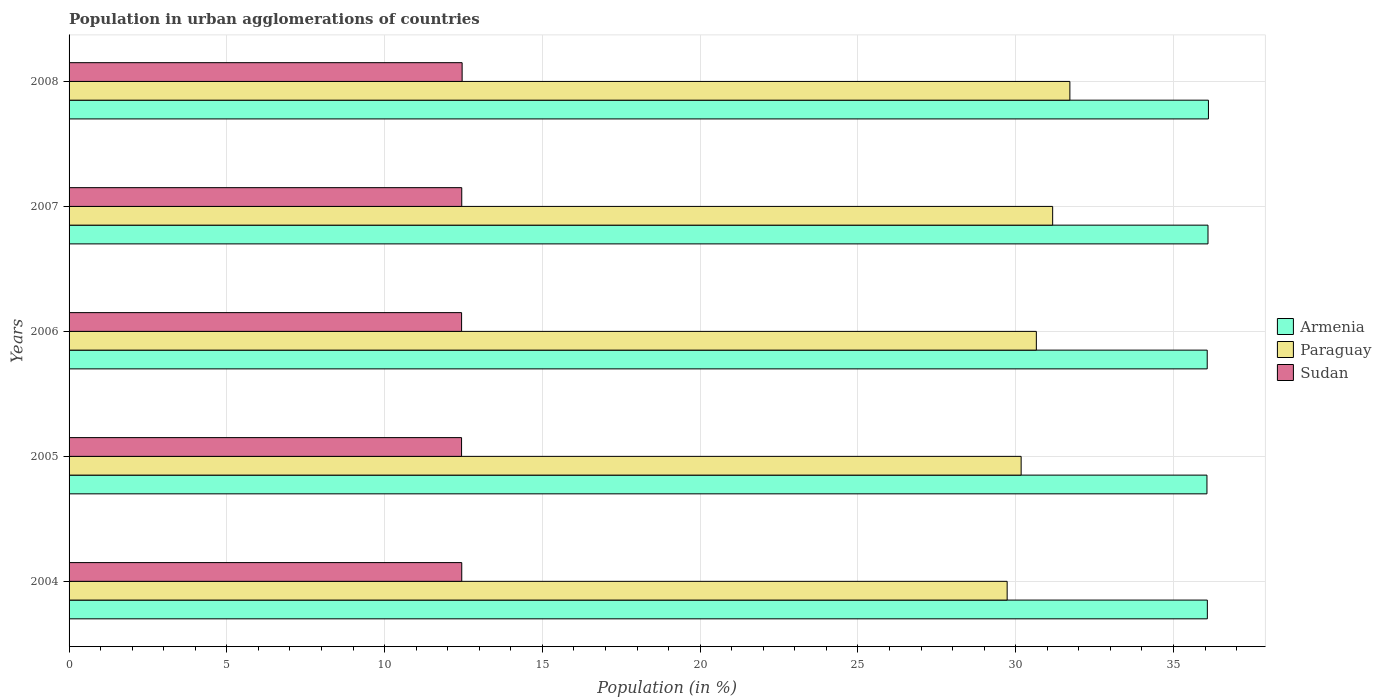How many different coloured bars are there?
Your answer should be compact. 3. How many groups of bars are there?
Give a very brief answer. 5. In how many cases, is the number of bars for a given year not equal to the number of legend labels?
Provide a succinct answer. 0. What is the percentage of population in urban agglomerations in Sudan in 2005?
Make the answer very short. 12.44. Across all years, what is the maximum percentage of population in urban agglomerations in Paraguay?
Your response must be concise. 31.72. Across all years, what is the minimum percentage of population in urban agglomerations in Sudan?
Keep it short and to the point. 12.44. In which year was the percentage of population in urban agglomerations in Sudan maximum?
Provide a short and direct response. 2008. What is the total percentage of population in urban agglomerations in Paraguay in the graph?
Provide a succinct answer. 153.44. What is the difference between the percentage of population in urban agglomerations in Paraguay in 2006 and that in 2008?
Provide a short and direct response. -1.06. What is the difference between the percentage of population in urban agglomerations in Armenia in 2004 and the percentage of population in urban agglomerations in Sudan in 2007?
Keep it short and to the point. 23.63. What is the average percentage of population in urban agglomerations in Sudan per year?
Make the answer very short. 12.44. In the year 2007, what is the difference between the percentage of population in urban agglomerations in Sudan and percentage of population in urban agglomerations in Armenia?
Ensure brevity in your answer.  -23.65. What is the ratio of the percentage of population in urban agglomerations in Armenia in 2004 to that in 2007?
Provide a succinct answer. 1. Is the percentage of population in urban agglomerations in Armenia in 2007 less than that in 2008?
Your answer should be compact. Yes. Is the difference between the percentage of population in urban agglomerations in Sudan in 2005 and 2008 greater than the difference between the percentage of population in urban agglomerations in Armenia in 2005 and 2008?
Your response must be concise. Yes. What is the difference between the highest and the second highest percentage of population in urban agglomerations in Sudan?
Give a very brief answer. 0.01. What is the difference between the highest and the lowest percentage of population in urban agglomerations in Armenia?
Keep it short and to the point. 0.05. Is the sum of the percentage of population in urban agglomerations in Armenia in 2005 and 2007 greater than the maximum percentage of population in urban agglomerations in Sudan across all years?
Ensure brevity in your answer.  Yes. What does the 3rd bar from the top in 2008 represents?
Offer a terse response. Armenia. What does the 2nd bar from the bottom in 2005 represents?
Ensure brevity in your answer.  Paraguay. How many bars are there?
Provide a succinct answer. 15. Are all the bars in the graph horizontal?
Offer a terse response. Yes. How many years are there in the graph?
Your answer should be very brief. 5. What is the difference between two consecutive major ticks on the X-axis?
Provide a short and direct response. 5. Are the values on the major ticks of X-axis written in scientific E-notation?
Make the answer very short. No. Does the graph contain any zero values?
Your answer should be very brief. No. Does the graph contain grids?
Offer a very short reply. Yes. How are the legend labels stacked?
Your response must be concise. Vertical. What is the title of the graph?
Provide a succinct answer. Population in urban agglomerations of countries. What is the label or title of the Y-axis?
Provide a succinct answer. Years. What is the Population (in %) in Armenia in 2004?
Offer a very short reply. 36.07. What is the Population (in %) of Paraguay in 2004?
Provide a short and direct response. 29.73. What is the Population (in %) in Sudan in 2004?
Provide a short and direct response. 12.44. What is the Population (in %) of Armenia in 2005?
Make the answer very short. 36.06. What is the Population (in %) of Paraguay in 2005?
Keep it short and to the point. 30.17. What is the Population (in %) in Sudan in 2005?
Your answer should be compact. 12.44. What is the Population (in %) in Armenia in 2006?
Give a very brief answer. 36.07. What is the Population (in %) of Paraguay in 2006?
Provide a succinct answer. 30.65. What is the Population (in %) in Sudan in 2006?
Your response must be concise. 12.44. What is the Population (in %) of Armenia in 2007?
Offer a very short reply. 36.09. What is the Population (in %) in Paraguay in 2007?
Your response must be concise. 31.17. What is the Population (in %) in Sudan in 2007?
Keep it short and to the point. 12.44. What is the Population (in %) of Armenia in 2008?
Your answer should be very brief. 36.11. What is the Population (in %) in Paraguay in 2008?
Offer a terse response. 31.72. What is the Population (in %) of Sudan in 2008?
Offer a terse response. 12.46. Across all years, what is the maximum Population (in %) of Armenia?
Your answer should be compact. 36.11. Across all years, what is the maximum Population (in %) of Paraguay?
Keep it short and to the point. 31.72. Across all years, what is the maximum Population (in %) of Sudan?
Provide a succinct answer. 12.46. Across all years, what is the minimum Population (in %) of Armenia?
Keep it short and to the point. 36.06. Across all years, what is the minimum Population (in %) of Paraguay?
Give a very brief answer. 29.73. Across all years, what is the minimum Population (in %) in Sudan?
Keep it short and to the point. 12.44. What is the total Population (in %) in Armenia in the graph?
Offer a terse response. 180.4. What is the total Population (in %) of Paraguay in the graph?
Provide a short and direct response. 153.44. What is the total Population (in %) of Sudan in the graph?
Give a very brief answer. 62.22. What is the difference between the Population (in %) of Armenia in 2004 and that in 2005?
Your answer should be compact. 0.01. What is the difference between the Population (in %) of Paraguay in 2004 and that in 2005?
Your answer should be very brief. -0.44. What is the difference between the Population (in %) of Sudan in 2004 and that in 2005?
Your answer should be compact. 0.01. What is the difference between the Population (in %) of Armenia in 2004 and that in 2006?
Make the answer very short. 0. What is the difference between the Population (in %) in Paraguay in 2004 and that in 2006?
Offer a terse response. -0.93. What is the difference between the Population (in %) of Sudan in 2004 and that in 2006?
Provide a succinct answer. 0. What is the difference between the Population (in %) of Armenia in 2004 and that in 2007?
Provide a short and direct response. -0.02. What is the difference between the Population (in %) in Paraguay in 2004 and that in 2007?
Your answer should be very brief. -1.44. What is the difference between the Population (in %) of Sudan in 2004 and that in 2007?
Your response must be concise. -0. What is the difference between the Population (in %) of Armenia in 2004 and that in 2008?
Your answer should be very brief. -0.03. What is the difference between the Population (in %) in Paraguay in 2004 and that in 2008?
Ensure brevity in your answer.  -1.99. What is the difference between the Population (in %) in Sudan in 2004 and that in 2008?
Your response must be concise. -0.01. What is the difference between the Population (in %) in Armenia in 2005 and that in 2006?
Provide a succinct answer. -0.01. What is the difference between the Population (in %) in Paraguay in 2005 and that in 2006?
Your response must be concise. -0.48. What is the difference between the Population (in %) of Sudan in 2005 and that in 2006?
Keep it short and to the point. -0. What is the difference between the Population (in %) in Armenia in 2005 and that in 2007?
Offer a terse response. -0.03. What is the difference between the Population (in %) of Paraguay in 2005 and that in 2007?
Your response must be concise. -1. What is the difference between the Population (in %) in Sudan in 2005 and that in 2007?
Ensure brevity in your answer.  -0.01. What is the difference between the Population (in %) of Armenia in 2005 and that in 2008?
Offer a terse response. -0.05. What is the difference between the Population (in %) of Paraguay in 2005 and that in 2008?
Keep it short and to the point. -1.54. What is the difference between the Population (in %) in Sudan in 2005 and that in 2008?
Ensure brevity in your answer.  -0.02. What is the difference between the Population (in %) of Armenia in 2006 and that in 2007?
Your answer should be compact. -0.02. What is the difference between the Population (in %) in Paraguay in 2006 and that in 2007?
Your answer should be compact. -0.52. What is the difference between the Population (in %) of Sudan in 2006 and that in 2007?
Offer a very short reply. -0. What is the difference between the Population (in %) of Armenia in 2006 and that in 2008?
Offer a very short reply. -0.04. What is the difference between the Population (in %) of Paraguay in 2006 and that in 2008?
Keep it short and to the point. -1.06. What is the difference between the Population (in %) in Sudan in 2006 and that in 2008?
Make the answer very short. -0.02. What is the difference between the Population (in %) of Armenia in 2007 and that in 2008?
Provide a short and direct response. -0.01. What is the difference between the Population (in %) in Paraguay in 2007 and that in 2008?
Your answer should be compact. -0.55. What is the difference between the Population (in %) in Sudan in 2007 and that in 2008?
Provide a succinct answer. -0.01. What is the difference between the Population (in %) in Armenia in 2004 and the Population (in %) in Paraguay in 2005?
Provide a short and direct response. 5.9. What is the difference between the Population (in %) in Armenia in 2004 and the Population (in %) in Sudan in 2005?
Offer a terse response. 23.63. What is the difference between the Population (in %) of Paraguay in 2004 and the Population (in %) of Sudan in 2005?
Keep it short and to the point. 17.29. What is the difference between the Population (in %) of Armenia in 2004 and the Population (in %) of Paraguay in 2006?
Keep it short and to the point. 5.42. What is the difference between the Population (in %) in Armenia in 2004 and the Population (in %) in Sudan in 2006?
Make the answer very short. 23.63. What is the difference between the Population (in %) of Paraguay in 2004 and the Population (in %) of Sudan in 2006?
Keep it short and to the point. 17.29. What is the difference between the Population (in %) in Armenia in 2004 and the Population (in %) in Paraguay in 2007?
Your answer should be compact. 4.9. What is the difference between the Population (in %) of Armenia in 2004 and the Population (in %) of Sudan in 2007?
Provide a short and direct response. 23.63. What is the difference between the Population (in %) of Paraguay in 2004 and the Population (in %) of Sudan in 2007?
Offer a very short reply. 17.28. What is the difference between the Population (in %) of Armenia in 2004 and the Population (in %) of Paraguay in 2008?
Offer a very short reply. 4.36. What is the difference between the Population (in %) in Armenia in 2004 and the Population (in %) in Sudan in 2008?
Keep it short and to the point. 23.62. What is the difference between the Population (in %) in Paraguay in 2004 and the Population (in %) in Sudan in 2008?
Offer a very short reply. 17.27. What is the difference between the Population (in %) in Armenia in 2005 and the Population (in %) in Paraguay in 2006?
Your answer should be very brief. 5.41. What is the difference between the Population (in %) of Armenia in 2005 and the Population (in %) of Sudan in 2006?
Your response must be concise. 23.62. What is the difference between the Population (in %) of Paraguay in 2005 and the Population (in %) of Sudan in 2006?
Your response must be concise. 17.73. What is the difference between the Population (in %) of Armenia in 2005 and the Population (in %) of Paraguay in 2007?
Provide a short and direct response. 4.89. What is the difference between the Population (in %) of Armenia in 2005 and the Population (in %) of Sudan in 2007?
Your response must be concise. 23.62. What is the difference between the Population (in %) in Paraguay in 2005 and the Population (in %) in Sudan in 2007?
Keep it short and to the point. 17.73. What is the difference between the Population (in %) of Armenia in 2005 and the Population (in %) of Paraguay in 2008?
Ensure brevity in your answer.  4.34. What is the difference between the Population (in %) in Armenia in 2005 and the Population (in %) in Sudan in 2008?
Your answer should be very brief. 23.6. What is the difference between the Population (in %) of Paraguay in 2005 and the Population (in %) of Sudan in 2008?
Ensure brevity in your answer.  17.71. What is the difference between the Population (in %) of Armenia in 2006 and the Population (in %) of Paraguay in 2007?
Give a very brief answer. 4.9. What is the difference between the Population (in %) of Armenia in 2006 and the Population (in %) of Sudan in 2007?
Give a very brief answer. 23.62. What is the difference between the Population (in %) of Paraguay in 2006 and the Population (in %) of Sudan in 2007?
Ensure brevity in your answer.  18.21. What is the difference between the Population (in %) in Armenia in 2006 and the Population (in %) in Paraguay in 2008?
Make the answer very short. 4.35. What is the difference between the Population (in %) of Armenia in 2006 and the Population (in %) of Sudan in 2008?
Keep it short and to the point. 23.61. What is the difference between the Population (in %) of Paraguay in 2006 and the Population (in %) of Sudan in 2008?
Provide a succinct answer. 18.2. What is the difference between the Population (in %) in Armenia in 2007 and the Population (in %) in Paraguay in 2008?
Offer a very short reply. 4.38. What is the difference between the Population (in %) of Armenia in 2007 and the Population (in %) of Sudan in 2008?
Your answer should be very brief. 23.64. What is the difference between the Population (in %) in Paraguay in 2007 and the Population (in %) in Sudan in 2008?
Make the answer very short. 18.71. What is the average Population (in %) of Armenia per year?
Ensure brevity in your answer.  36.08. What is the average Population (in %) of Paraguay per year?
Provide a short and direct response. 30.69. What is the average Population (in %) of Sudan per year?
Offer a very short reply. 12.44. In the year 2004, what is the difference between the Population (in %) in Armenia and Population (in %) in Paraguay?
Your answer should be compact. 6.34. In the year 2004, what is the difference between the Population (in %) of Armenia and Population (in %) of Sudan?
Offer a terse response. 23.63. In the year 2004, what is the difference between the Population (in %) of Paraguay and Population (in %) of Sudan?
Give a very brief answer. 17.28. In the year 2005, what is the difference between the Population (in %) in Armenia and Population (in %) in Paraguay?
Your answer should be very brief. 5.89. In the year 2005, what is the difference between the Population (in %) of Armenia and Population (in %) of Sudan?
Provide a short and direct response. 23.62. In the year 2005, what is the difference between the Population (in %) of Paraguay and Population (in %) of Sudan?
Provide a short and direct response. 17.73. In the year 2006, what is the difference between the Population (in %) in Armenia and Population (in %) in Paraguay?
Offer a very short reply. 5.42. In the year 2006, what is the difference between the Population (in %) of Armenia and Population (in %) of Sudan?
Your answer should be very brief. 23.63. In the year 2006, what is the difference between the Population (in %) of Paraguay and Population (in %) of Sudan?
Your answer should be very brief. 18.21. In the year 2007, what is the difference between the Population (in %) in Armenia and Population (in %) in Paraguay?
Ensure brevity in your answer.  4.92. In the year 2007, what is the difference between the Population (in %) in Armenia and Population (in %) in Sudan?
Provide a succinct answer. 23.65. In the year 2007, what is the difference between the Population (in %) of Paraguay and Population (in %) of Sudan?
Keep it short and to the point. 18.73. In the year 2008, what is the difference between the Population (in %) in Armenia and Population (in %) in Paraguay?
Offer a terse response. 4.39. In the year 2008, what is the difference between the Population (in %) in Armenia and Population (in %) in Sudan?
Give a very brief answer. 23.65. In the year 2008, what is the difference between the Population (in %) of Paraguay and Population (in %) of Sudan?
Your response must be concise. 19.26. What is the ratio of the Population (in %) of Armenia in 2004 to that in 2005?
Offer a very short reply. 1. What is the ratio of the Population (in %) of Paraguay in 2004 to that in 2005?
Your response must be concise. 0.99. What is the ratio of the Population (in %) of Sudan in 2004 to that in 2005?
Provide a short and direct response. 1. What is the ratio of the Population (in %) in Armenia in 2004 to that in 2006?
Offer a very short reply. 1. What is the ratio of the Population (in %) in Paraguay in 2004 to that in 2006?
Offer a terse response. 0.97. What is the ratio of the Population (in %) of Sudan in 2004 to that in 2006?
Offer a terse response. 1. What is the ratio of the Population (in %) of Paraguay in 2004 to that in 2007?
Your response must be concise. 0.95. What is the ratio of the Population (in %) in Armenia in 2004 to that in 2008?
Your response must be concise. 1. What is the ratio of the Population (in %) in Paraguay in 2004 to that in 2008?
Offer a terse response. 0.94. What is the ratio of the Population (in %) of Armenia in 2005 to that in 2006?
Keep it short and to the point. 1. What is the ratio of the Population (in %) of Paraguay in 2005 to that in 2006?
Your answer should be very brief. 0.98. What is the ratio of the Population (in %) of Armenia in 2005 to that in 2008?
Your response must be concise. 1. What is the ratio of the Population (in %) of Paraguay in 2005 to that in 2008?
Provide a short and direct response. 0.95. What is the ratio of the Population (in %) in Sudan in 2005 to that in 2008?
Your response must be concise. 1. What is the ratio of the Population (in %) in Paraguay in 2006 to that in 2007?
Offer a terse response. 0.98. What is the ratio of the Population (in %) of Paraguay in 2006 to that in 2008?
Your answer should be very brief. 0.97. What is the ratio of the Population (in %) of Sudan in 2006 to that in 2008?
Make the answer very short. 1. What is the ratio of the Population (in %) of Armenia in 2007 to that in 2008?
Offer a very short reply. 1. What is the ratio of the Population (in %) in Paraguay in 2007 to that in 2008?
Your answer should be very brief. 0.98. What is the difference between the highest and the second highest Population (in %) of Armenia?
Your response must be concise. 0.01. What is the difference between the highest and the second highest Population (in %) of Paraguay?
Your answer should be very brief. 0.55. What is the difference between the highest and the second highest Population (in %) of Sudan?
Offer a very short reply. 0.01. What is the difference between the highest and the lowest Population (in %) in Armenia?
Your answer should be very brief. 0.05. What is the difference between the highest and the lowest Population (in %) of Paraguay?
Give a very brief answer. 1.99. What is the difference between the highest and the lowest Population (in %) of Sudan?
Your answer should be compact. 0.02. 